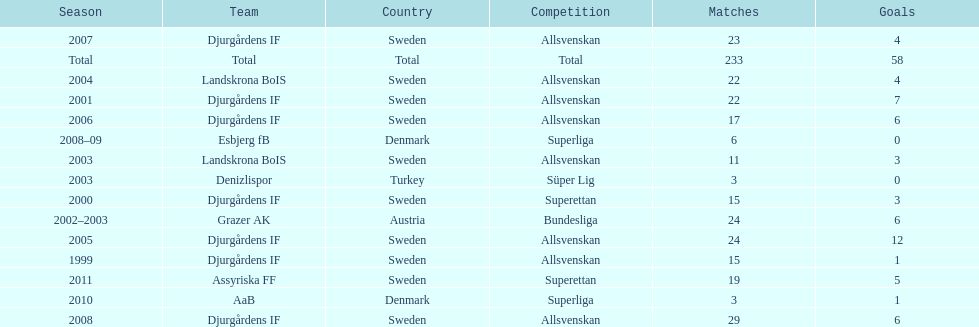What is the total number of matches? 233. 